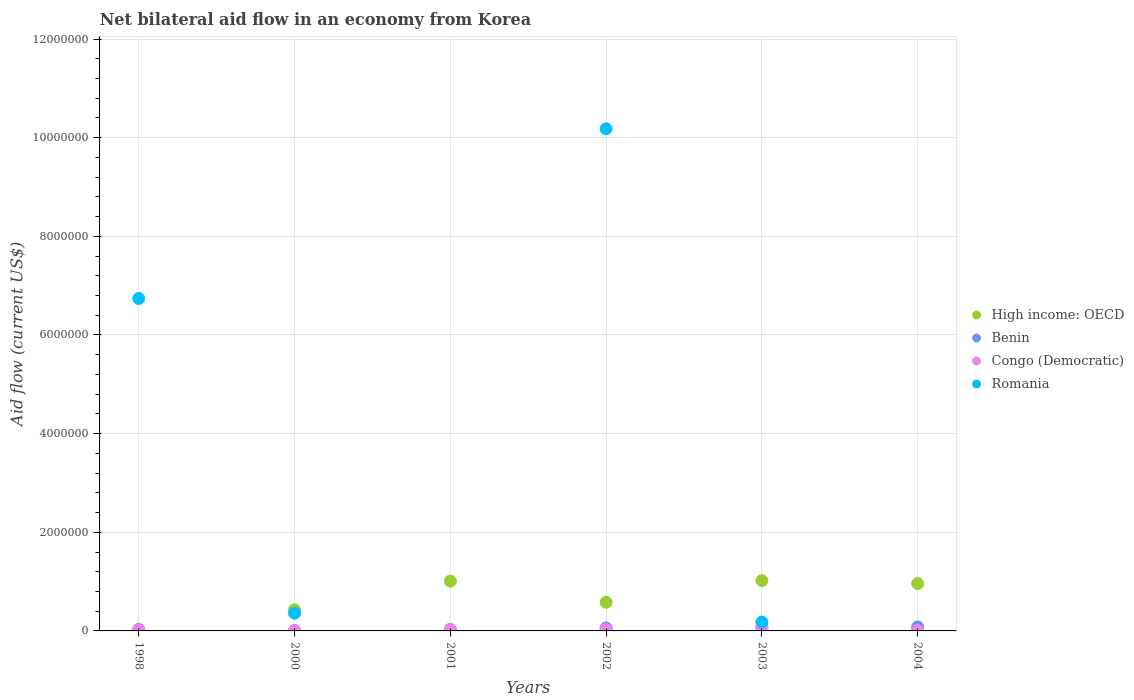How many different coloured dotlines are there?
Your answer should be compact. 4. In which year was the net bilateral aid flow in High income: OECD maximum?
Provide a short and direct response. 2003. What is the difference between the net bilateral aid flow in Benin in 2002 and that in 2004?
Your answer should be compact. -2.00e+04. What is the difference between the net bilateral aid flow in Congo (Democratic) in 1998 and the net bilateral aid flow in Benin in 2002?
Provide a succinct answer. -4.00e+04. What is the average net bilateral aid flow in Benin per year?
Your answer should be very brief. 4.67e+04. In the year 2001, what is the difference between the net bilateral aid flow in Congo (Democratic) and net bilateral aid flow in High income: OECD?
Offer a terse response. -9.80e+05. Is the net bilateral aid flow in Benin in 2000 less than that in 2003?
Offer a very short reply. Yes. In how many years, is the net bilateral aid flow in High income: OECD greater than the average net bilateral aid flow in High income: OECD taken over all years?
Ensure brevity in your answer.  3. Does the net bilateral aid flow in Benin monotonically increase over the years?
Offer a very short reply. No. Is the net bilateral aid flow in Benin strictly less than the net bilateral aid flow in High income: OECD over the years?
Provide a short and direct response. No. How many dotlines are there?
Offer a terse response. 4. What is the difference between two consecutive major ticks on the Y-axis?
Give a very brief answer. 2.00e+06. Does the graph contain grids?
Provide a succinct answer. Yes. Where does the legend appear in the graph?
Offer a very short reply. Center right. How are the legend labels stacked?
Provide a succinct answer. Vertical. What is the title of the graph?
Your response must be concise. Net bilateral aid flow in an economy from Korea. Does "United Arab Emirates" appear as one of the legend labels in the graph?
Offer a terse response. No. What is the label or title of the X-axis?
Provide a succinct answer. Years. What is the label or title of the Y-axis?
Make the answer very short. Aid flow (current US$). What is the Aid flow (current US$) of Benin in 1998?
Your response must be concise. 3.00e+04. What is the Aid flow (current US$) in Romania in 1998?
Your answer should be compact. 6.74e+06. What is the Aid flow (current US$) in High income: OECD in 2000?
Offer a very short reply. 4.30e+05. What is the Aid flow (current US$) in Romania in 2000?
Provide a short and direct response. 3.60e+05. What is the Aid flow (current US$) in High income: OECD in 2001?
Your response must be concise. 1.01e+06. What is the Aid flow (current US$) in Romania in 2001?
Make the answer very short. 0. What is the Aid flow (current US$) in High income: OECD in 2002?
Offer a very short reply. 5.80e+05. What is the Aid flow (current US$) in Benin in 2002?
Keep it short and to the point. 6.00e+04. What is the Aid flow (current US$) in Romania in 2002?
Your answer should be compact. 1.02e+07. What is the Aid flow (current US$) in High income: OECD in 2003?
Offer a terse response. 1.02e+06. What is the Aid flow (current US$) of Romania in 2003?
Make the answer very short. 1.80e+05. What is the Aid flow (current US$) in High income: OECD in 2004?
Ensure brevity in your answer.  9.60e+05. What is the Aid flow (current US$) in Benin in 2004?
Ensure brevity in your answer.  8.00e+04. Across all years, what is the maximum Aid flow (current US$) of High income: OECD?
Offer a terse response. 1.02e+06. Across all years, what is the maximum Aid flow (current US$) of Benin?
Offer a terse response. 8.00e+04. Across all years, what is the maximum Aid flow (current US$) in Congo (Democratic)?
Your answer should be very brief. 7.00e+04. Across all years, what is the maximum Aid flow (current US$) in Romania?
Offer a very short reply. 1.02e+07. Across all years, what is the minimum Aid flow (current US$) in High income: OECD?
Keep it short and to the point. 0. Across all years, what is the minimum Aid flow (current US$) of Congo (Democratic)?
Provide a succinct answer. 10000. Across all years, what is the minimum Aid flow (current US$) in Romania?
Make the answer very short. 0. What is the total Aid flow (current US$) of High income: OECD in the graph?
Offer a terse response. 4.00e+06. What is the total Aid flow (current US$) of Benin in the graph?
Provide a succinct answer. 2.80e+05. What is the total Aid flow (current US$) of Romania in the graph?
Your response must be concise. 1.75e+07. What is the difference between the Aid flow (current US$) of Benin in 1998 and that in 2000?
Offer a very short reply. 2.00e+04. What is the difference between the Aid flow (current US$) in Congo (Democratic) in 1998 and that in 2000?
Offer a very short reply. 10000. What is the difference between the Aid flow (current US$) of Romania in 1998 and that in 2000?
Make the answer very short. 6.38e+06. What is the difference between the Aid flow (current US$) in Benin in 1998 and that in 2001?
Make the answer very short. 0. What is the difference between the Aid flow (current US$) of Romania in 1998 and that in 2002?
Offer a very short reply. -3.44e+06. What is the difference between the Aid flow (current US$) of Benin in 1998 and that in 2003?
Provide a short and direct response. -4.00e+04. What is the difference between the Aid flow (current US$) in Romania in 1998 and that in 2003?
Provide a succinct answer. 6.56e+06. What is the difference between the Aid flow (current US$) of Congo (Democratic) in 1998 and that in 2004?
Your answer should be very brief. 10000. What is the difference between the Aid flow (current US$) in High income: OECD in 2000 and that in 2001?
Give a very brief answer. -5.80e+05. What is the difference between the Aid flow (current US$) in Benin in 2000 and that in 2001?
Your response must be concise. -2.00e+04. What is the difference between the Aid flow (current US$) in Congo (Democratic) in 2000 and that in 2001?
Make the answer very short. -2.00e+04. What is the difference between the Aid flow (current US$) in Benin in 2000 and that in 2002?
Give a very brief answer. -5.00e+04. What is the difference between the Aid flow (current US$) in Congo (Democratic) in 2000 and that in 2002?
Your answer should be compact. -2.00e+04. What is the difference between the Aid flow (current US$) of Romania in 2000 and that in 2002?
Give a very brief answer. -9.82e+06. What is the difference between the Aid flow (current US$) of High income: OECD in 2000 and that in 2003?
Keep it short and to the point. -5.90e+05. What is the difference between the Aid flow (current US$) in Benin in 2000 and that in 2003?
Make the answer very short. -6.00e+04. What is the difference between the Aid flow (current US$) of High income: OECD in 2000 and that in 2004?
Make the answer very short. -5.30e+05. What is the difference between the Aid flow (current US$) in Congo (Democratic) in 2001 and that in 2002?
Your answer should be compact. 0. What is the difference between the Aid flow (current US$) in High income: OECD in 2001 and that in 2004?
Make the answer very short. 5.00e+04. What is the difference between the Aid flow (current US$) in Benin in 2001 and that in 2004?
Offer a very short reply. -5.00e+04. What is the difference between the Aid flow (current US$) in High income: OECD in 2002 and that in 2003?
Offer a very short reply. -4.40e+05. What is the difference between the Aid flow (current US$) of Congo (Democratic) in 2002 and that in 2003?
Your answer should be compact. -4.00e+04. What is the difference between the Aid flow (current US$) in High income: OECD in 2002 and that in 2004?
Offer a terse response. -3.80e+05. What is the difference between the Aid flow (current US$) in Congo (Democratic) in 2002 and that in 2004?
Your answer should be very brief. 2.00e+04. What is the difference between the Aid flow (current US$) in High income: OECD in 2003 and that in 2004?
Your answer should be very brief. 6.00e+04. What is the difference between the Aid flow (current US$) in Congo (Democratic) in 2003 and that in 2004?
Offer a terse response. 6.00e+04. What is the difference between the Aid flow (current US$) in Benin in 1998 and the Aid flow (current US$) in Congo (Democratic) in 2000?
Offer a terse response. 2.00e+04. What is the difference between the Aid flow (current US$) in Benin in 1998 and the Aid flow (current US$) in Romania in 2000?
Provide a succinct answer. -3.30e+05. What is the difference between the Aid flow (current US$) in Congo (Democratic) in 1998 and the Aid flow (current US$) in Romania in 2000?
Make the answer very short. -3.40e+05. What is the difference between the Aid flow (current US$) in Benin in 1998 and the Aid flow (current US$) in Congo (Democratic) in 2002?
Ensure brevity in your answer.  0. What is the difference between the Aid flow (current US$) of Benin in 1998 and the Aid flow (current US$) of Romania in 2002?
Your answer should be very brief. -1.02e+07. What is the difference between the Aid flow (current US$) of Congo (Democratic) in 1998 and the Aid flow (current US$) of Romania in 2002?
Provide a short and direct response. -1.02e+07. What is the difference between the Aid flow (current US$) of Benin in 1998 and the Aid flow (current US$) of Congo (Democratic) in 2003?
Keep it short and to the point. -4.00e+04. What is the difference between the Aid flow (current US$) of Benin in 1998 and the Aid flow (current US$) of Romania in 2003?
Your response must be concise. -1.50e+05. What is the difference between the Aid flow (current US$) of Congo (Democratic) in 1998 and the Aid flow (current US$) of Romania in 2003?
Your answer should be very brief. -1.60e+05. What is the difference between the Aid flow (current US$) in Benin in 1998 and the Aid flow (current US$) in Congo (Democratic) in 2004?
Provide a short and direct response. 2.00e+04. What is the difference between the Aid flow (current US$) of High income: OECD in 2000 and the Aid flow (current US$) of Benin in 2001?
Provide a succinct answer. 4.00e+05. What is the difference between the Aid flow (current US$) of Benin in 2000 and the Aid flow (current US$) of Congo (Democratic) in 2001?
Your answer should be very brief. -2.00e+04. What is the difference between the Aid flow (current US$) in High income: OECD in 2000 and the Aid flow (current US$) in Romania in 2002?
Your answer should be very brief. -9.75e+06. What is the difference between the Aid flow (current US$) in Benin in 2000 and the Aid flow (current US$) in Congo (Democratic) in 2002?
Provide a short and direct response. -2.00e+04. What is the difference between the Aid flow (current US$) of Benin in 2000 and the Aid flow (current US$) of Romania in 2002?
Keep it short and to the point. -1.02e+07. What is the difference between the Aid flow (current US$) in Congo (Democratic) in 2000 and the Aid flow (current US$) in Romania in 2002?
Offer a very short reply. -1.02e+07. What is the difference between the Aid flow (current US$) of Benin in 2000 and the Aid flow (current US$) of Romania in 2003?
Offer a very short reply. -1.70e+05. What is the difference between the Aid flow (current US$) of Congo (Democratic) in 2000 and the Aid flow (current US$) of Romania in 2003?
Offer a very short reply. -1.70e+05. What is the difference between the Aid flow (current US$) in High income: OECD in 2000 and the Aid flow (current US$) in Congo (Democratic) in 2004?
Offer a terse response. 4.20e+05. What is the difference between the Aid flow (current US$) in High income: OECD in 2001 and the Aid flow (current US$) in Benin in 2002?
Provide a succinct answer. 9.50e+05. What is the difference between the Aid flow (current US$) in High income: OECD in 2001 and the Aid flow (current US$) in Congo (Democratic) in 2002?
Give a very brief answer. 9.80e+05. What is the difference between the Aid flow (current US$) of High income: OECD in 2001 and the Aid flow (current US$) of Romania in 2002?
Give a very brief answer. -9.17e+06. What is the difference between the Aid flow (current US$) of Benin in 2001 and the Aid flow (current US$) of Congo (Democratic) in 2002?
Keep it short and to the point. 0. What is the difference between the Aid flow (current US$) in Benin in 2001 and the Aid flow (current US$) in Romania in 2002?
Provide a succinct answer. -1.02e+07. What is the difference between the Aid flow (current US$) of Congo (Democratic) in 2001 and the Aid flow (current US$) of Romania in 2002?
Your answer should be compact. -1.02e+07. What is the difference between the Aid flow (current US$) in High income: OECD in 2001 and the Aid flow (current US$) in Benin in 2003?
Make the answer very short. 9.40e+05. What is the difference between the Aid flow (current US$) in High income: OECD in 2001 and the Aid flow (current US$) in Congo (Democratic) in 2003?
Make the answer very short. 9.40e+05. What is the difference between the Aid flow (current US$) of High income: OECD in 2001 and the Aid flow (current US$) of Romania in 2003?
Keep it short and to the point. 8.30e+05. What is the difference between the Aid flow (current US$) in High income: OECD in 2001 and the Aid flow (current US$) in Benin in 2004?
Make the answer very short. 9.30e+05. What is the difference between the Aid flow (current US$) in High income: OECD in 2001 and the Aid flow (current US$) in Congo (Democratic) in 2004?
Keep it short and to the point. 1.00e+06. What is the difference between the Aid flow (current US$) of Benin in 2001 and the Aid flow (current US$) of Congo (Democratic) in 2004?
Provide a short and direct response. 2.00e+04. What is the difference between the Aid flow (current US$) in High income: OECD in 2002 and the Aid flow (current US$) in Benin in 2003?
Your response must be concise. 5.10e+05. What is the difference between the Aid flow (current US$) in High income: OECD in 2002 and the Aid flow (current US$) in Congo (Democratic) in 2003?
Your answer should be compact. 5.10e+05. What is the difference between the Aid flow (current US$) of High income: OECD in 2002 and the Aid flow (current US$) of Romania in 2003?
Provide a short and direct response. 4.00e+05. What is the difference between the Aid flow (current US$) of Benin in 2002 and the Aid flow (current US$) of Romania in 2003?
Ensure brevity in your answer.  -1.20e+05. What is the difference between the Aid flow (current US$) in Congo (Democratic) in 2002 and the Aid flow (current US$) in Romania in 2003?
Make the answer very short. -1.50e+05. What is the difference between the Aid flow (current US$) of High income: OECD in 2002 and the Aid flow (current US$) of Benin in 2004?
Provide a short and direct response. 5.00e+05. What is the difference between the Aid flow (current US$) of High income: OECD in 2002 and the Aid flow (current US$) of Congo (Democratic) in 2004?
Your answer should be very brief. 5.70e+05. What is the difference between the Aid flow (current US$) of Benin in 2002 and the Aid flow (current US$) of Congo (Democratic) in 2004?
Your answer should be compact. 5.00e+04. What is the difference between the Aid flow (current US$) of High income: OECD in 2003 and the Aid flow (current US$) of Benin in 2004?
Offer a terse response. 9.40e+05. What is the difference between the Aid flow (current US$) in High income: OECD in 2003 and the Aid flow (current US$) in Congo (Democratic) in 2004?
Give a very brief answer. 1.01e+06. What is the average Aid flow (current US$) of High income: OECD per year?
Provide a short and direct response. 6.67e+05. What is the average Aid flow (current US$) of Benin per year?
Offer a very short reply. 4.67e+04. What is the average Aid flow (current US$) of Congo (Democratic) per year?
Give a very brief answer. 2.83e+04. What is the average Aid flow (current US$) in Romania per year?
Provide a short and direct response. 2.91e+06. In the year 1998, what is the difference between the Aid flow (current US$) of Benin and Aid flow (current US$) of Congo (Democratic)?
Your answer should be compact. 10000. In the year 1998, what is the difference between the Aid flow (current US$) in Benin and Aid flow (current US$) in Romania?
Provide a succinct answer. -6.71e+06. In the year 1998, what is the difference between the Aid flow (current US$) in Congo (Democratic) and Aid flow (current US$) in Romania?
Offer a very short reply. -6.72e+06. In the year 2000, what is the difference between the Aid flow (current US$) in High income: OECD and Aid flow (current US$) in Benin?
Provide a short and direct response. 4.20e+05. In the year 2000, what is the difference between the Aid flow (current US$) of High income: OECD and Aid flow (current US$) of Congo (Democratic)?
Give a very brief answer. 4.20e+05. In the year 2000, what is the difference between the Aid flow (current US$) of Benin and Aid flow (current US$) of Romania?
Provide a succinct answer. -3.50e+05. In the year 2000, what is the difference between the Aid flow (current US$) of Congo (Democratic) and Aid flow (current US$) of Romania?
Your answer should be very brief. -3.50e+05. In the year 2001, what is the difference between the Aid flow (current US$) of High income: OECD and Aid flow (current US$) of Benin?
Keep it short and to the point. 9.80e+05. In the year 2001, what is the difference between the Aid flow (current US$) in High income: OECD and Aid flow (current US$) in Congo (Democratic)?
Ensure brevity in your answer.  9.80e+05. In the year 2001, what is the difference between the Aid flow (current US$) in Benin and Aid flow (current US$) in Congo (Democratic)?
Provide a short and direct response. 0. In the year 2002, what is the difference between the Aid flow (current US$) in High income: OECD and Aid flow (current US$) in Benin?
Your response must be concise. 5.20e+05. In the year 2002, what is the difference between the Aid flow (current US$) of High income: OECD and Aid flow (current US$) of Congo (Democratic)?
Make the answer very short. 5.50e+05. In the year 2002, what is the difference between the Aid flow (current US$) in High income: OECD and Aid flow (current US$) in Romania?
Your answer should be very brief. -9.60e+06. In the year 2002, what is the difference between the Aid flow (current US$) of Benin and Aid flow (current US$) of Congo (Democratic)?
Keep it short and to the point. 3.00e+04. In the year 2002, what is the difference between the Aid flow (current US$) of Benin and Aid flow (current US$) of Romania?
Your answer should be compact. -1.01e+07. In the year 2002, what is the difference between the Aid flow (current US$) of Congo (Democratic) and Aid flow (current US$) of Romania?
Ensure brevity in your answer.  -1.02e+07. In the year 2003, what is the difference between the Aid flow (current US$) of High income: OECD and Aid flow (current US$) of Benin?
Your response must be concise. 9.50e+05. In the year 2003, what is the difference between the Aid flow (current US$) in High income: OECD and Aid flow (current US$) in Congo (Democratic)?
Keep it short and to the point. 9.50e+05. In the year 2003, what is the difference between the Aid flow (current US$) in High income: OECD and Aid flow (current US$) in Romania?
Your response must be concise. 8.40e+05. In the year 2003, what is the difference between the Aid flow (current US$) in Benin and Aid flow (current US$) in Romania?
Give a very brief answer. -1.10e+05. In the year 2003, what is the difference between the Aid flow (current US$) of Congo (Democratic) and Aid flow (current US$) of Romania?
Ensure brevity in your answer.  -1.10e+05. In the year 2004, what is the difference between the Aid flow (current US$) of High income: OECD and Aid flow (current US$) of Benin?
Provide a succinct answer. 8.80e+05. In the year 2004, what is the difference between the Aid flow (current US$) of High income: OECD and Aid flow (current US$) of Congo (Democratic)?
Provide a succinct answer. 9.50e+05. What is the ratio of the Aid flow (current US$) in Benin in 1998 to that in 2000?
Provide a short and direct response. 3. What is the ratio of the Aid flow (current US$) of Congo (Democratic) in 1998 to that in 2000?
Provide a succinct answer. 2. What is the ratio of the Aid flow (current US$) of Romania in 1998 to that in 2000?
Your answer should be very brief. 18.72. What is the ratio of the Aid flow (current US$) in Congo (Democratic) in 1998 to that in 2002?
Your answer should be very brief. 0.67. What is the ratio of the Aid flow (current US$) of Romania in 1998 to that in 2002?
Keep it short and to the point. 0.66. What is the ratio of the Aid flow (current US$) of Benin in 1998 to that in 2003?
Keep it short and to the point. 0.43. What is the ratio of the Aid flow (current US$) in Congo (Democratic) in 1998 to that in 2003?
Keep it short and to the point. 0.29. What is the ratio of the Aid flow (current US$) of Romania in 1998 to that in 2003?
Offer a terse response. 37.44. What is the ratio of the Aid flow (current US$) in Congo (Democratic) in 1998 to that in 2004?
Make the answer very short. 2. What is the ratio of the Aid flow (current US$) of High income: OECD in 2000 to that in 2001?
Offer a terse response. 0.43. What is the ratio of the Aid flow (current US$) in Benin in 2000 to that in 2001?
Your response must be concise. 0.33. What is the ratio of the Aid flow (current US$) of Congo (Democratic) in 2000 to that in 2001?
Your answer should be very brief. 0.33. What is the ratio of the Aid flow (current US$) in High income: OECD in 2000 to that in 2002?
Provide a short and direct response. 0.74. What is the ratio of the Aid flow (current US$) in Congo (Democratic) in 2000 to that in 2002?
Your answer should be compact. 0.33. What is the ratio of the Aid flow (current US$) in Romania in 2000 to that in 2002?
Keep it short and to the point. 0.04. What is the ratio of the Aid flow (current US$) of High income: OECD in 2000 to that in 2003?
Your response must be concise. 0.42. What is the ratio of the Aid flow (current US$) of Benin in 2000 to that in 2003?
Your response must be concise. 0.14. What is the ratio of the Aid flow (current US$) in Congo (Democratic) in 2000 to that in 2003?
Your answer should be very brief. 0.14. What is the ratio of the Aid flow (current US$) of Romania in 2000 to that in 2003?
Give a very brief answer. 2. What is the ratio of the Aid flow (current US$) of High income: OECD in 2000 to that in 2004?
Your response must be concise. 0.45. What is the ratio of the Aid flow (current US$) in Congo (Democratic) in 2000 to that in 2004?
Provide a short and direct response. 1. What is the ratio of the Aid flow (current US$) of High income: OECD in 2001 to that in 2002?
Offer a terse response. 1.74. What is the ratio of the Aid flow (current US$) of Congo (Democratic) in 2001 to that in 2002?
Provide a succinct answer. 1. What is the ratio of the Aid flow (current US$) in High income: OECD in 2001 to that in 2003?
Offer a terse response. 0.99. What is the ratio of the Aid flow (current US$) in Benin in 2001 to that in 2003?
Make the answer very short. 0.43. What is the ratio of the Aid flow (current US$) of Congo (Democratic) in 2001 to that in 2003?
Give a very brief answer. 0.43. What is the ratio of the Aid flow (current US$) of High income: OECD in 2001 to that in 2004?
Your answer should be very brief. 1.05. What is the ratio of the Aid flow (current US$) of Benin in 2001 to that in 2004?
Ensure brevity in your answer.  0.38. What is the ratio of the Aid flow (current US$) in Congo (Democratic) in 2001 to that in 2004?
Your response must be concise. 3. What is the ratio of the Aid flow (current US$) in High income: OECD in 2002 to that in 2003?
Provide a short and direct response. 0.57. What is the ratio of the Aid flow (current US$) in Congo (Democratic) in 2002 to that in 2003?
Provide a succinct answer. 0.43. What is the ratio of the Aid flow (current US$) in Romania in 2002 to that in 2003?
Offer a very short reply. 56.56. What is the ratio of the Aid flow (current US$) of High income: OECD in 2002 to that in 2004?
Your answer should be very brief. 0.6. What is the ratio of the Aid flow (current US$) of Congo (Democratic) in 2002 to that in 2004?
Your answer should be very brief. 3. What is the ratio of the Aid flow (current US$) in High income: OECD in 2003 to that in 2004?
Your response must be concise. 1.06. What is the ratio of the Aid flow (current US$) in Congo (Democratic) in 2003 to that in 2004?
Your response must be concise. 7. What is the difference between the highest and the second highest Aid flow (current US$) in High income: OECD?
Your response must be concise. 10000. What is the difference between the highest and the second highest Aid flow (current US$) of Benin?
Offer a very short reply. 10000. What is the difference between the highest and the second highest Aid flow (current US$) of Congo (Democratic)?
Provide a short and direct response. 4.00e+04. What is the difference between the highest and the second highest Aid flow (current US$) in Romania?
Your answer should be very brief. 3.44e+06. What is the difference between the highest and the lowest Aid flow (current US$) of High income: OECD?
Your answer should be very brief. 1.02e+06. What is the difference between the highest and the lowest Aid flow (current US$) of Benin?
Your answer should be compact. 7.00e+04. What is the difference between the highest and the lowest Aid flow (current US$) of Congo (Democratic)?
Offer a very short reply. 6.00e+04. What is the difference between the highest and the lowest Aid flow (current US$) in Romania?
Give a very brief answer. 1.02e+07. 